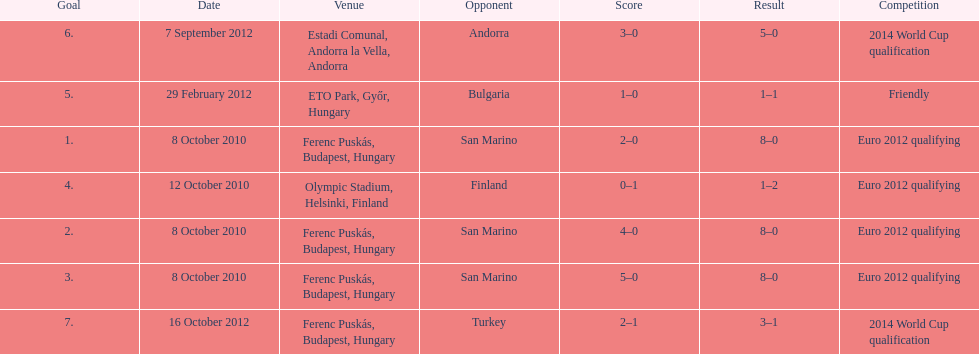In what year did ádám szalai make his next international goal after 2010? 2012. 